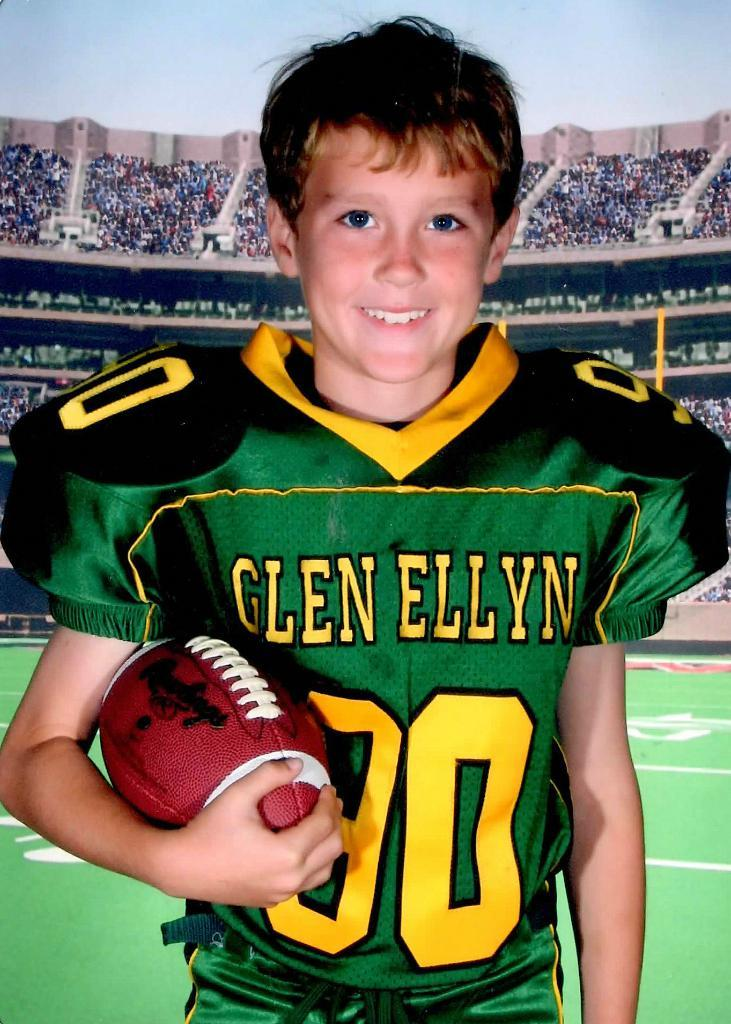Provide a one-sentence caption for the provided image. A child with a green jersey that has the name Glen Ellyn on it. 